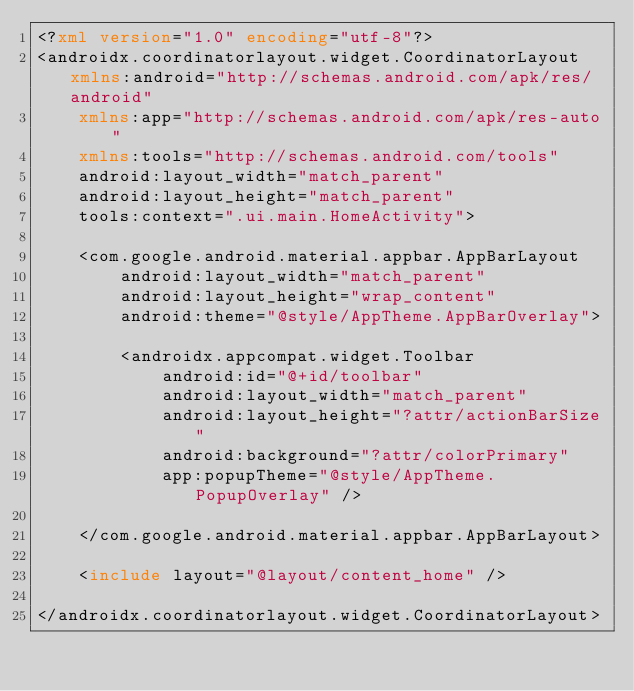<code> <loc_0><loc_0><loc_500><loc_500><_XML_><?xml version="1.0" encoding="utf-8"?>
<androidx.coordinatorlayout.widget.CoordinatorLayout xmlns:android="http://schemas.android.com/apk/res/android"
    xmlns:app="http://schemas.android.com/apk/res-auto"
    xmlns:tools="http://schemas.android.com/tools"
    android:layout_width="match_parent"
    android:layout_height="match_parent"
    tools:context=".ui.main.HomeActivity">

    <com.google.android.material.appbar.AppBarLayout
        android:layout_width="match_parent"
        android:layout_height="wrap_content"
        android:theme="@style/AppTheme.AppBarOverlay">

        <androidx.appcompat.widget.Toolbar
            android:id="@+id/toolbar"
            android:layout_width="match_parent"
            android:layout_height="?attr/actionBarSize"
            android:background="?attr/colorPrimary"
            app:popupTheme="@style/AppTheme.PopupOverlay" />

    </com.google.android.material.appbar.AppBarLayout>

    <include layout="@layout/content_home" />

</androidx.coordinatorlayout.widget.CoordinatorLayout></code> 